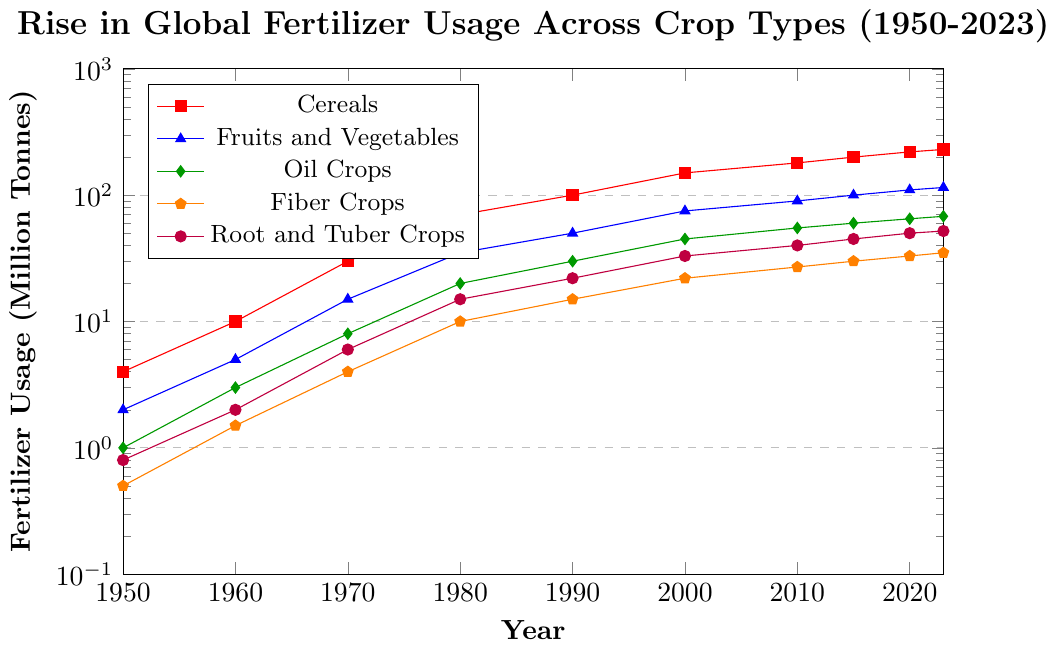What crop type shows the highest increase in fertilizer usage from 1950 to 2023? To find the crop type with the highest increase, look at the starting and ending values of fertilizer usage for each crop type. Subtract the initial value from the final value for each crop type. Cereals: 230 - 4 = 226, Fruits and Vegetables: 115 - 2 = 113, Oil Crops: 68 - 1 = 67, Fiber Crops: 35 - 0.5 = 34.5, Root and Tuber Crops: 52 - 0.8 = 51.2. The crop with the highest increase is Cereals.
Answer: Cereals By how much did fertilizer usage for Fruits and Vegetables change between 1980 and 2020? Subtract the fertilizer usage in 1980 from the usage in 2020 for Fruits and Vegetables. From the data, 2020 value: 110, 1980 value: 35. The change is 110 - 35.
Answer: 75 Which crop had the lowest fertilizer usage in 1950 and what was its usage in 2023? Identify the crop with the minimum value in 1950 and then find its value in 2023. In 1950, Oil Crops had the lowest usage at 1 million tonnes. In 2023, the usage was 68 million tonnes for Oil Crops.
Answer: Oil Crops had 1 million tonnes in 1950 and 68 million tonnes in 2023 Compare the growth of fertilizer usage for Fiber Crops and Root and Tuber Crops from 1970 to 2023. Which one increased more? Calculate the difference for both crop types from 1970 to 2023. Fiber Crops: 35 - 4 = 31, Root and Tuber Crops: 52 - 6 = 46. Root and Tuber Crops show a greater increase.
Answer: Root and Tuber Crops increased more During which decade did Cereals see the largest increase in fertilizer usage? To find the largest increase, compute the difference in fertilizer usage for Cereals for each decade: 1960: 10 - 4 = 6, 1970: 30 - 10 = 20, 1980: 70 - 30 = 40, 1990: 100 - 70 = 30, 2000: 150 - 100 = 50, 2010: 180 - 150 = 30, 2015: 200 - 180 = 20, 2020: 220 - 200 = 20, 2023: 230 - 220 = 10. The largest increase in a decade is from 1990 to 2000.
Answer: 1990s How does the trend of Oil Crops' fertilizer usage compare to Cereals' from 1950 to 2023? Compare the trend lines visually. Oil Crops show a steady rise, but at a slower rate compared to the steep incline seen in Cereals' usage. Cereals start higher and grow more rapidly across the years.
Answer: Cereals show a steeper and faster increase What is the average fertilizer usage for Fiber Crops across all years provided? Sum the values of Fiber Crops from all years and divide by the number of data points. (0.5 + 1.5 + 4 + 10 + 15 + 22 + 27 + 30 + 33 + 35) / 10 = 18.3
Answer: 18.3 million tonnes By what factor has root and tuber crops' fertilizer usage increased from 1950 to 2023? Divide the fertilizer usage in 2023 by the usage in 1950 for root and tuber crops. 52 / 0.8 = 65
Answer: 65 Which crop had the closest fertilizer usage to 100 million tonnes in the year 2000? Compare the values of each crop in the year 2000. Cereals: 150, Fruits and Vegetables: 75, Oil Crops: 45, Fiber Crops: 22, Root and Tuber Crops: 33. Fruits and Vegetables are the closest to 100 million tonnes.
Answer: Fruits and Vegetables What is the absolute difference in fertilizer usage between Cereals and Root and Tuber Crops in 2023? Subtract the fertilizer usage of Root and Tuber Crops from that of Cereals in 2023. 230 - 52 = 178
Answer: 178 million tonnes 